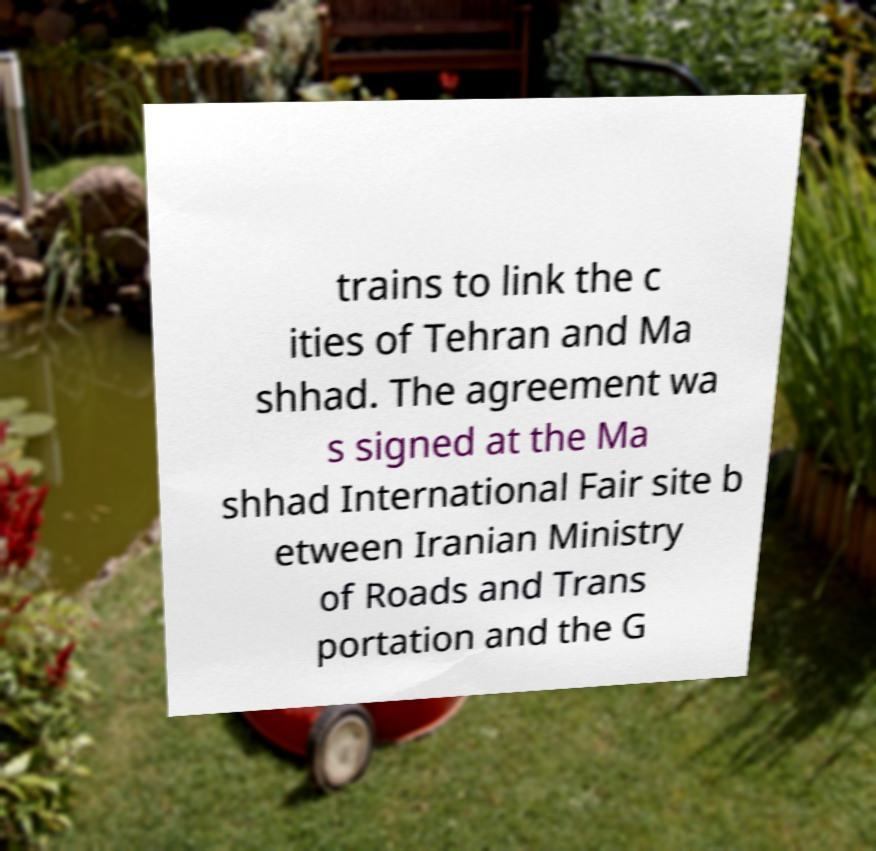Please identify and transcribe the text found in this image. trains to link the c ities of Tehran and Ma shhad. The agreement wa s signed at the Ma shhad International Fair site b etween Iranian Ministry of Roads and Trans portation and the G 